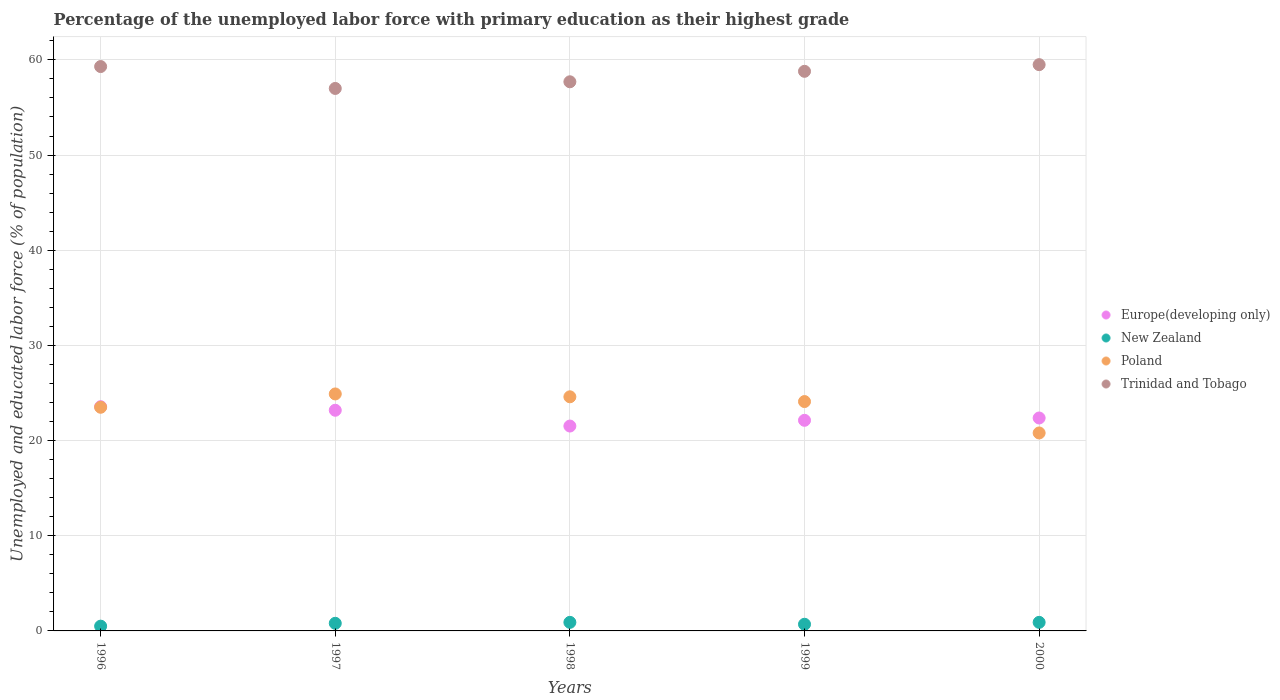How many different coloured dotlines are there?
Make the answer very short. 4. Is the number of dotlines equal to the number of legend labels?
Offer a terse response. Yes. What is the percentage of the unemployed labor force with primary education in Trinidad and Tobago in 2000?
Offer a very short reply. 59.5. Across all years, what is the maximum percentage of the unemployed labor force with primary education in Europe(developing only)?
Keep it short and to the point. 23.56. Across all years, what is the minimum percentage of the unemployed labor force with primary education in Trinidad and Tobago?
Your response must be concise. 57. In which year was the percentage of the unemployed labor force with primary education in Trinidad and Tobago maximum?
Offer a terse response. 2000. In which year was the percentage of the unemployed labor force with primary education in Europe(developing only) minimum?
Provide a succinct answer. 1998. What is the total percentage of the unemployed labor force with primary education in Poland in the graph?
Give a very brief answer. 117.9. What is the difference between the percentage of the unemployed labor force with primary education in New Zealand in 1997 and that in 1998?
Offer a terse response. -0.1. What is the difference between the percentage of the unemployed labor force with primary education in Poland in 1997 and the percentage of the unemployed labor force with primary education in Europe(developing only) in 1999?
Your answer should be compact. 2.77. What is the average percentage of the unemployed labor force with primary education in Europe(developing only) per year?
Make the answer very short. 22.56. In the year 1999, what is the difference between the percentage of the unemployed labor force with primary education in Poland and percentage of the unemployed labor force with primary education in Trinidad and Tobago?
Give a very brief answer. -34.7. What is the ratio of the percentage of the unemployed labor force with primary education in Poland in 1996 to that in 1997?
Give a very brief answer. 0.94. Is the percentage of the unemployed labor force with primary education in New Zealand in 1996 less than that in 2000?
Your answer should be very brief. Yes. What is the difference between the highest and the second highest percentage of the unemployed labor force with primary education in Trinidad and Tobago?
Ensure brevity in your answer.  0.2. What is the difference between the highest and the lowest percentage of the unemployed labor force with primary education in New Zealand?
Your answer should be compact. 0.4. Is the sum of the percentage of the unemployed labor force with primary education in New Zealand in 1997 and 1999 greater than the maximum percentage of the unemployed labor force with primary education in Europe(developing only) across all years?
Give a very brief answer. No. Is it the case that in every year, the sum of the percentage of the unemployed labor force with primary education in New Zealand and percentage of the unemployed labor force with primary education in Poland  is greater than the sum of percentage of the unemployed labor force with primary education in Europe(developing only) and percentage of the unemployed labor force with primary education in Trinidad and Tobago?
Make the answer very short. No. Is the percentage of the unemployed labor force with primary education in Europe(developing only) strictly greater than the percentage of the unemployed labor force with primary education in Trinidad and Tobago over the years?
Provide a succinct answer. No. How many dotlines are there?
Provide a short and direct response. 4. What is the difference between two consecutive major ticks on the Y-axis?
Your answer should be very brief. 10. Does the graph contain any zero values?
Keep it short and to the point. No. Does the graph contain grids?
Give a very brief answer. Yes. Where does the legend appear in the graph?
Your response must be concise. Center right. How many legend labels are there?
Offer a very short reply. 4. What is the title of the graph?
Your answer should be compact. Percentage of the unemployed labor force with primary education as their highest grade. What is the label or title of the Y-axis?
Provide a short and direct response. Unemployed and educated labor force (% of population). What is the Unemployed and educated labor force (% of population) of Europe(developing only) in 1996?
Make the answer very short. 23.56. What is the Unemployed and educated labor force (% of population) of New Zealand in 1996?
Offer a very short reply. 0.5. What is the Unemployed and educated labor force (% of population) of Trinidad and Tobago in 1996?
Your answer should be very brief. 59.3. What is the Unemployed and educated labor force (% of population) in Europe(developing only) in 1997?
Offer a terse response. 23.19. What is the Unemployed and educated labor force (% of population) in New Zealand in 1997?
Your response must be concise. 0.8. What is the Unemployed and educated labor force (% of population) of Poland in 1997?
Make the answer very short. 24.9. What is the Unemployed and educated labor force (% of population) of Trinidad and Tobago in 1997?
Your answer should be very brief. 57. What is the Unemployed and educated labor force (% of population) of Europe(developing only) in 1998?
Offer a very short reply. 21.53. What is the Unemployed and educated labor force (% of population) of New Zealand in 1998?
Offer a very short reply. 0.9. What is the Unemployed and educated labor force (% of population) of Poland in 1998?
Keep it short and to the point. 24.6. What is the Unemployed and educated labor force (% of population) in Trinidad and Tobago in 1998?
Offer a terse response. 57.7. What is the Unemployed and educated labor force (% of population) in Europe(developing only) in 1999?
Make the answer very short. 22.13. What is the Unemployed and educated labor force (% of population) of New Zealand in 1999?
Ensure brevity in your answer.  0.7. What is the Unemployed and educated labor force (% of population) of Poland in 1999?
Your answer should be compact. 24.1. What is the Unemployed and educated labor force (% of population) of Trinidad and Tobago in 1999?
Give a very brief answer. 58.8. What is the Unemployed and educated labor force (% of population) in Europe(developing only) in 2000?
Make the answer very short. 22.37. What is the Unemployed and educated labor force (% of population) in New Zealand in 2000?
Provide a succinct answer. 0.9. What is the Unemployed and educated labor force (% of population) of Poland in 2000?
Provide a succinct answer. 20.8. What is the Unemployed and educated labor force (% of population) of Trinidad and Tobago in 2000?
Your answer should be very brief. 59.5. Across all years, what is the maximum Unemployed and educated labor force (% of population) of Europe(developing only)?
Offer a terse response. 23.56. Across all years, what is the maximum Unemployed and educated labor force (% of population) of New Zealand?
Provide a succinct answer. 0.9. Across all years, what is the maximum Unemployed and educated labor force (% of population) of Poland?
Offer a terse response. 24.9. Across all years, what is the maximum Unemployed and educated labor force (% of population) in Trinidad and Tobago?
Keep it short and to the point. 59.5. Across all years, what is the minimum Unemployed and educated labor force (% of population) in Europe(developing only)?
Provide a short and direct response. 21.53. Across all years, what is the minimum Unemployed and educated labor force (% of population) of New Zealand?
Offer a very short reply. 0.5. Across all years, what is the minimum Unemployed and educated labor force (% of population) of Poland?
Keep it short and to the point. 20.8. What is the total Unemployed and educated labor force (% of population) of Europe(developing only) in the graph?
Your answer should be very brief. 112.78. What is the total Unemployed and educated labor force (% of population) of New Zealand in the graph?
Your answer should be compact. 3.8. What is the total Unemployed and educated labor force (% of population) of Poland in the graph?
Make the answer very short. 117.9. What is the total Unemployed and educated labor force (% of population) of Trinidad and Tobago in the graph?
Ensure brevity in your answer.  292.3. What is the difference between the Unemployed and educated labor force (% of population) of Europe(developing only) in 1996 and that in 1997?
Keep it short and to the point. 0.37. What is the difference between the Unemployed and educated labor force (% of population) of New Zealand in 1996 and that in 1997?
Provide a short and direct response. -0.3. What is the difference between the Unemployed and educated labor force (% of population) in Poland in 1996 and that in 1997?
Offer a very short reply. -1.4. What is the difference between the Unemployed and educated labor force (% of population) in Trinidad and Tobago in 1996 and that in 1997?
Provide a succinct answer. 2.3. What is the difference between the Unemployed and educated labor force (% of population) of Europe(developing only) in 1996 and that in 1998?
Ensure brevity in your answer.  2.03. What is the difference between the Unemployed and educated labor force (% of population) in Europe(developing only) in 1996 and that in 1999?
Your answer should be very brief. 1.43. What is the difference between the Unemployed and educated labor force (% of population) in New Zealand in 1996 and that in 1999?
Give a very brief answer. -0.2. What is the difference between the Unemployed and educated labor force (% of population) of Europe(developing only) in 1996 and that in 2000?
Your answer should be very brief. 1.19. What is the difference between the Unemployed and educated labor force (% of population) of Poland in 1996 and that in 2000?
Provide a succinct answer. 2.7. What is the difference between the Unemployed and educated labor force (% of population) in Europe(developing only) in 1997 and that in 1998?
Your response must be concise. 1.66. What is the difference between the Unemployed and educated labor force (% of population) in Poland in 1997 and that in 1998?
Offer a terse response. 0.3. What is the difference between the Unemployed and educated labor force (% of population) of Europe(developing only) in 1997 and that in 1999?
Your response must be concise. 1.06. What is the difference between the Unemployed and educated labor force (% of population) of Europe(developing only) in 1997 and that in 2000?
Your answer should be compact. 0.81. What is the difference between the Unemployed and educated labor force (% of population) in Trinidad and Tobago in 1997 and that in 2000?
Provide a succinct answer. -2.5. What is the difference between the Unemployed and educated labor force (% of population) in Europe(developing only) in 1998 and that in 1999?
Offer a terse response. -0.6. What is the difference between the Unemployed and educated labor force (% of population) in New Zealand in 1998 and that in 1999?
Offer a very short reply. 0.2. What is the difference between the Unemployed and educated labor force (% of population) in Poland in 1998 and that in 1999?
Provide a succinct answer. 0.5. What is the difference between the Unemployed and educated labor force (% of population) in Trinidad and Tobago in 1998 and that in 1999?
Offer a terse response. -1.1. What is the difference between the Unemployed and educated labor force (% of population) in Europe(developing only) in 1998 and that in 2000?
Your answer should be compact. -0.85. What is the difference between the Unemployed and educated labor force (% of population) in New Zealand in 1998 and that in 2000?
Ensure brevity in your answer.  0. What is the difference between the Unemployed and educated labor force (% of population) in Trinidad and Tobago in 1998 and that in 2000?
Provide a short and direct response. -1.8. What is the difference between the Unemployed and educated labor force (% of population) of Europe(developing only) in 1999 and that in 2000?
Your answer should be compact. -0.24. What is the difference between the Unemployed and educated labor force (% of population) in Europe(developing only) in 1996 and the Unemployed and educated labor force (% of population) in New Zealand in 1997?
Offer a terse response. 22.76. What is the difference between the Unemployed and educated labor force (% of population) of Europe(developing only) in 1996 and the Unemployed and educated labor force (% of population) of Poland in 1997?
Offer a terse response. -1.34. What is the difference between the Unemployed and educated labor force (% of population) of Europe(developing only) in 1996 and the Unemployed and educated labor force (% of population) of Trinidad and Tobago in 1997?
Your response must be concise. -33.44. What is the difference between the Unemployed and educated labor force (% of population) of New Zealand in 1996 and the Unemployed and educated labor force (% of population) of Poland in 1997?
Your response must be concise. -24.4. What is the difference between the Unemployed and educated labor force (% of population) in New Zealand in 1996 and the Unemployed and educated labor force (% of population) in Trinidad and Tobago in 1997?
Keep it short and to the point. -56.5. What is the difference between the Unemployed and educated labor force (% of population) of Poland in 1996 and the Unemployed and educated labor force (% of population) of Trinidad and Tobago in 1997?
Provide a short and direct response. -33.5. What is the difference between the Unemployed and educated labor force (% of population) of Europe(developing only) in 1996 and the Unemployed and educated labor force (% of population) of New Zealand in 1998?
Keep it short and to the point. 22.66. What is the difference between the Unemployed and educated labor force (% of population) in Europe(developing only) in 1996 and the Unemployed and educated labor force (% of population) in Poland in 1998?
Your response must be concise. -1.04. What is the difference between the Unemployed and educated labor force (% of population) in Europe(developing only) in 1996 and the Unemployed and educated labor force (% of population) in Trinidad and Tobago in 1998?
Ensure brevity in your answer.  -34.14. What is the difference between the Unemployed and educated labor force (% of population) in New Zealand in 1996 and the Unemployed and educated labor force (% of population) in Poland in 1998?
Provide a succinct answer. -24.1. What is the difference between the Unemployed and educated labor force (% of population) of New Zealand in 1996 and the Unemployed and educated labor force (% of population) of Trinidad and Tobago in 1998?
Your response must be concise. -57.2. What is the difference between the Unemployed and educated labor force (% of population) in Poland in 1996 and the Unemployed and educated labor force (% of population) in Trinidad and Tobago in 1998?
Provide a short and direct response. -34.2. What is the difference between the Unemployed and educated labor force (% of population) of Europe(developing only) in 1996 and the Unemployed and educated labor force (% of population) of New Zealand in 1999?
Make the answer very short. 22.86. What is the difference between the Unemployed and educated labor force (% of population) in Europe(developing only) in 1996 and the Unemployed and educated labor force (% of population) in Poland in 1999?
Offer a very short reply. -0.54. What is the difference between the Unemployed and educated labor force (% of population) of Europe(developing only) in 1996 and the Unemployed and educated labor force (% of population) of Trinidad and Tobago in 1999?
Your response must be concise. -35.24. What is the difference between the Unemployed and educated labor force (% of population) of New Zealand in 1996 and the Unemployed and educated labor force (% of population) of Poland in 1999?
Offer a terse response. -23.6. What is the difference between the Unemployed and educated labor force (% of population) of New Zealand in 1996 and the Unemployed and educated labor force (% of population) of Trinidad and Tobago in 1999?
Make the answer very short. -58.3. What is the difference between the Unemployed and educated labor force (% of population) in Poland in 1996 and the Unemployed and educated labor force (% of population) in Trinidad and Tobago in 1999?
Your answer should be very brief. -35.3. What is the difference between the Unemployed and educated labor force (% of population) of Europe(developing only) in 1996 and the Unemployed and educated labor force (% of population) of New Zealand in 2000?
Keep it short and to the point. 22.66. What is the difference between the Unemployed and educated labor force (% of population) in Europe(developing only) in 1996 and the Unemployed and educated labor force (% of population) in Poland in 2000?
Provide a short and direct response. 2.76. What is the difference between the Unemployed and educated labor force (% of population) in Europe(developing only) in 1996 and the Unemployed and educated labor force (% of population) in Trinidad and Tobago in 2000?
Ensure brevity in your answer.  -35.94. What is the difference between the Unemployed and educated labor force (% of population) in New Zealand in 1996 and the Unemployed and educated labor force (% of population) in Poland in 2000?
Provide a short and direct response. -20.3. What is the difference between the Unemployed and educated labor force (% of population) of New Zealand in 1996 and the Unemployed and educated labor force (% of population) of Trinidad and Tobago in 2000?
Ensure brevity in your answer.  -59. What is the difference between the Unemployed and educated labor force (% of population) in Poland in 1996 and the Unemployed and educated labor force (% of population) in Trinidad and Tobago in 2000?
Keep it short and to the point. -36. What is the difference between the Unemployed and educated labor force (% of population) in Europe(developing only) in 1997 and the Unemployed and educated labor force (% of population) in New Zealand in 1998?
Ensure brevity in your answer.  22.29. What is the difference between the Unemployed and educated labor force (% of population) of Europe(developing only) in 1997 and the Unemployed and educated labor force (% of population) of Poland in 1998?
Provide a succinct answer. -1.41. What is the difference between the Unemployed and educated labor force (% of population) in Europe(developing only) in 1997 and the Unemployed and educated labor force (% of population) in Trinidad and Tobago in 1998?
Offer a terse response. -34.51. What is the difference between the Unemployed and educated labor force (% of population) of New Zealand in 1997 and the Unemployed and educated labor force (% of population) of Poland in 1998?
Make the answer very short. -23.8. What is the difference between the Unemployed and educated labor force (% of population) in New Zealand in 1997 and the Unemployed and educated labor force (% of population) in Trinidad and Tobago in 1998?
Ensure brevity in your answer.  -56.9. What is the difference between the Unemployed and educated labor force (% of population) of Poland in 1997 and the Unemployed and educated labor force (% of population) of Trinidad and Tobago in 1998?
Your response must be concise. -32.8. What is the difference between the Unemployed and educated labor force (% of population) in Europe(developing only) in 1997 and the Unemployed and educated labor force (% of population) in New Zealand in 1999?
Your answer should be compact. 22.49. What is the difference between the Unemployed and educated labor force (% of population) of Europe(developing only) in 1997 and the Unemployed and educated labor force (% of population) of Poland in 1999?
Keep it short and to the point. -0.91. What is the difference between the Unemployed and educated labor force (% of population) of Europe(developing only) in 1997 and the Unemployed and educated labor force (% of population) of Trinidad and Tobago in 1999?
Your response must be concise. -35.61. What is the difference between the Unemployed and educated labor force (% of population) in New Zealand in 1997 and the Unemployed and educated labor force (% of population) in Poland in 1999?
Keep it short and to the point. -23.3. What is the difference between the Unemployed and educated labor force (% of population) in New Zealand in 1997 and the Unemployed and educated labor force (% of population) in Trinidad and Tobago in 1999?
Your answer should be very brief. -58. What is the difference between the Unemployed and educated labor force (% of population) of Poland in 1997 and the Unemployed and educated labor force (% of population) of Trinidad and Tobago in 1999?
Ensure brevity in your answer.  -33.9. What is the difference between the Unemployed and educated labor force (% of population) of Europe(developing only) in 1997 and the Unemployed and educated labor force (% of population) of New Zealand in 2000?
Provide a succinct answer. 22.29. What is the difference between the Unemployed and educated labor force (% of population) of Europe(developing only) in 1997 and the Unemployed and educated labor force (% of population) of Poland in 2000?
Give a very brief answer. 2.39. What is the difference between the Unemployed and educated labor force (% of population) in Europe(developing only) in 1997 and the Unemployed and educated labor force (% of population) in Trinidad and Tobago in 2000?
Offer a terse response. -36.31. What is the difference between the Unemployed and educated labor force (% of population) of New Zealand in 1997 and the Unemployed and educated labor force (% of population) of Trinidad and Tobago in 2000?
Your answer should be very brief. -58.7. What is the difference between the Unemployed and educated labor force (% of population) in Poland in 1997 and the Unemployed and educated labor force (% of population) in Trinidad and Tobago in 2000?
Offer a terse response. -34.6. What is the difference between the Unemployed and educated labor force (% of population) in Europe(developing only) in 1998 and the Unemployed and educated labor force (% of population) in New Zealand in 1999?
Your answer should be very brief. 20.83. What is the difference between the Unemployed and educated labor force (% of population) of Europe(developing only) in 1998 and the Unemployed and educated labor force (% of population) of Poland in 1999?
Ensure brevity in your answer.  -2.57. What is the difference between the Unemployed and educated labor force (% of population) in Europe(developing only) in 1998 and the Unemployed and educated labor force (% of population) in Trinidad and Tobago in 1999?
Make the answer very short. -37.27. What is the difference between the Unemployed and educated labor force (% of population) of New Zealand in 1998 and the Unemployed and educated labor force (% of population) of Poland in 1999?
Offer a very short reply. -23.2. What is the difference between the Unemployed and educated labor force (% of population) in New Zealand in 1998 and the Unemployed and educated labor force (% of population) in Trinidad and Tobago in 1999?
Your answer should be compact. -57.9. What is the difference between the Unemployed and educated labor force (% of population) of Poland in 1998 and the Unemployed and educated labor force (% of population) of Trinidad and Tobago in 1999?
Your answer should be compact. -34.2. What is the difference between the Unemployed and educated labor force (% of population) of Europe(developing only) in 1998 and the Unemployed and educated labor force (% of population) of New Zealand in 2000?
Keep it short and to the point. 20.63. What is the difference between the Unemployed and educated labor force (% of population) of Europe(developing only) in 1998 and the Unemployed and educated labor force (% of population) of Poland in 2000?
Give a very brief answer. 0.73. What is the difference between the Unemployed and educated labor force (% of population) of Europe(developing only) in 1998 and the Unemployed and educated labor force (% of population) of Trinidad and Tobago in 2000?
Keep it short and to the point. -37.97. What is the difference between the Unemployed and educated labor force (% of population) in New Zealand in 1998 and the Unemployed and educated labor force (% of population) in Poland in 2000?
Make the answer very short. -19.9. What is the difference between the Unemployed and educated labor force (% of population) of New Zealand in 1998 and the Unemployed and educated labor force (% of population) of Trinidad and Tobago in 2000?
Your answer should be very brief. -58.6. What is the difference between the Unemployed and educated labor force (% of population) in Poland in 1998 and the Unemployed and educated labor force (% of population) in Trinidad and Tobago in 2000?
Provide a succinct answer. -34.9. What is the difference between the Unemployed and educated labor force (% of population) of Europe(developing only) in 1999 and the Unemployed and educated labor force (% of population) of New Zealand in 2000?
Ensure brevity in your answer.  21.23. What is the difference between the Unemployed and educated labor force (% of population) in Europe(developing only) in 1999 and the Unemployed and educated labor force (% of population) in Poland in 2000?
Give a very brief answer. 1.33. What is the difference between the Unemployed and educated labor force (% of population) of Europe(developing only) in 1999 and the Unemployed and educated labor force (% of population) of Trinidad and Tobago in 2000?
Your answer should be very brief. -37.37. What is the difference between the Unemployed and educated labor force (% of population) in New Zealand in 1999 and the Unemployed and educated labor force (% of population) in Poland in 2000?
Provide a short and direct response. -20.1. What is the difference between the Unemployed and educated labor force (% of population) of New Zealand in 1999 and the Unemployed and educated labor force (% of population) of Trinidad and Tobago in 2000?
Offer a very short reply. -58.8. What is the difference between the Unemployed and educated labor force (% of population) in Poland in 1999 and the Unemployed and educated labor force (% of population) in Trinidad and Tobago in 2000?
Your response must be concise. -35.4. What is the average Unemployed and educated labor force (% of population) in Europe(developing only) per year?
Your answer should be compact. 22.56. What is the average Unemployed and educated labor force (% of population) of New Zealand per year?
Offer a terse response. 0.76. What is the average Unemployed and educated labor force (% of population) of Poland per year?
Provide a succinct answer. 23.58. What is the average Unemployed and educated labor force (% of population) in Trinidad and Tobago per year?
Your answer should be very brief. 58.46. In the year 1996, what is the difference between the Unemployed and educated labor force (% of population) of Europe(developing only) and Unemployed and educated labor force (% of population) of New Zealand?
Offer a terse response. 23.06. In the year 1996, what is the difference between the Unemployed and educated labor force (% of population) in Europe(developing only) and Unemployed and educated labor force (% of population) in Poland?
Provide a short and direct response. 0.06. In the year 1996, what is the difference between the Unemployed and educated labor force (% of population) in Europe(developing only) and Unemployed and educated labor force (% of population) in Trinidad and Tobago?
Keep it short and to the point. -35.74. In the year 1996, what is the difference between the Unemployed and educated labor force (% of population) of New Zealand and Unemployed and educated labor force (% of population) of Poland?
Offer a very short reply. -23. In the year 1996, what is the difference between the Unemployed and educated labor force (% of population) in New Zealand and Unemployed and educated labor force (% of population) in Trinidad and Tobago?
Make the answer very short. -58.8. In the year 1996, what is the difference between the Unemployed and educated labor force (% of population) in Poland and Unemployed and educated labor force (% of population) in Trinidad and Tobago?
Ensure brevity in your answer.  -35.8. In the year 1997, what is the difference between the Unemployed and educated labor force (% of population) of Europe(developing only) and Unemployed and educated labor force (% of population) of New Zealand?
Ensure brevity in your answer.  22.39. In the year 1997, what is the difference between the Unemployed and educated labor force (% of population) of Europe(developing only) and Unemployed and educated labor force (% of population) of Poland?
Ensure brevity in your answer.  -1.71. In the year 1997, what is the difference between the Unemployed and educated labor force (% of population) in Europe(developing only) and Unemployed and educated labor force (% of population) in Trinidad and Tobago?
Keep it short and to the point. -33.81. In the year 1997, what is the difference between the Unemployed and educated labor force (% of population) in New Zealand and Unemployed and educated labor force (% of population) in Poland?
Your response must be concise. -24.1. In the year 1997, what is the difference between the Unemployed and educated labor force (% of population) in New Zealand and Unemployed and educated labor force (% of population) in Trinidad and Tobago?
Your response must be concise. -56.2. In the year 1997, what is the difference between the Unemployed and educated labor force (% of population) in Poland and Unemployed and educated labor force (% of population) in Trinidad and Tobago?
Keep it short and to the point. -32.1. In the year 1998, what is the difference between the Unemployed and educated labor force (% of population) in Europe(developing only) and Unemployed and educated labor force (% of population) in New Zealand?
Keep it short and to the point. 20.63. In the year 1998, what is the difference between the Unemployed and educated labor force (% of population) of Europe(developing only) and Unemployed and educated labor force (% of population) of Poland?
Your answer should be compact. -3.07. In the year 1998, what is the difference between the Unemployed and educated labor force (% of population) in Europe(developing only) and Unemployed and educated labor force (% of population) in Trinidad and Tobago?
Offer a terse response. -36.17. In the year 1998, what is the difference between the Unemployed and educated labor force (% of population) in New Zealand and Unemployed and educated labor force (% of population) in Poland?
Offer a terse response. -23.7. In the year 1998, what is the difference between the Unemployed and educated labor force (% of population) of New Zealand and Unemployed and educated labor force (% of population) of Trinidad and Tobago?
Provide a succinct answer. -56.8. In the year 1998, what is the difference between the Unemployed and educated labor force (% of population) of Poland and Unemployed and educated labor force (% of population) of Trinidad and Tobago?
Your answer should be very brief. -33.1. In the year 1999, what is the difference between the Unemployed and educated labor force (% of population) in Europe(developing only) and Unemployed and educated labor force (% of population) in New Zealand?
Ensure brevity in your answer.  21.43. In the year 1999, what is the difference between the Unemployed and educated labor force (% of population) of Europe(developing only) and Unemployed and educated labor force (% of population) of Poland?
Ensure brevity in your answer.  -1.97. In the year 1999, what is the difference between the Unemployed and educated labor force (% of population) in Europe(developing only) and Unemployed and educated labor force (% of population) in Trinidad and Tobago?
Your response must be concise. -36.67. In the year 1999, what is the difference between the Unemployed and educated labor force (% of population) of New Zealand and Unemployed and educated labor force (% of population) of Poland?
Offer a terse response. -23.4. In the year 1999, what is the difference between the Unemployed and educated labor force (% of population) in New Zealand and Unemployed and educated labor force (% of population) in Trinidad and Tobago?
Make the answer very short. -58.1. In the year 1999, what is the difference between the Unemployed and educated labor force (% of population) of Poland and Unemployed and educated labor force (% of population) of Trinidad and Tobago?
Your response must be concise. -34.7. In the year 2000, what is the difference between the Unemployed and educated labor force (% of population) of Europe(developing only) and Unemployed and educated labor force (% of population) of New Zealand?
Your answer should be compact. 21.47. In the year 2000, what is the difference between the Unemployed and educated labor force (% of population) of Europe(developing only) and Unemployed and educated labor force (% of population) of Poland?
Your response must be concise. 1.57. In the year 2000, what is the difference between the Unemployed and educated labor force (% of population) of Europe(developing only) and Unemployed and educated labor force (% of population) of Trinidad and Tobago?
Give a very brief answer. -37.13. In the year 2000, what is the difference between the Unemployed and educated labor force (% of population) in New Zealand and Unemployed and educated labor force (% of population) in Poland?
Offer a very short reply. -19.9. In the year 2000, what is the difference between the Unemployed and educated labor force (% of population) in New Zealand and Unemployed and educated labor force (% of population) in Trinidad and Tobago?
Keep it short and to the point. -58.6. In the year 2000, what is the difference between the Unemployed and educated labor force (% of population) of Poland and Unemployed and educated labor force (% of population) of Trinidad and Tobago?
Give a very brief answer. -38.7. What is the ratio of the Unemployed and educated labor force (% of population) in Europe(developing only) in 1996 to that in 1997?
Your answer should be very brief. 1.02. What is the ratio of the Unemployed and educated labor force (% of population) of New Zealand in 1996 to that in 1997?
Provide a short and direct response. 0.62. What is the ratio of the Unemployed and educated labor force (% of population) of Poland in 1996 to that in 1997?
Provide a short and direct response. 0.94. What is the ratio of the Unemployed and educated labor force (% of population) in Trinidad and Tobago in 1996 to that in 1997?
Your answer should be very brief. 1.04. What is the ratio of the Unemployed and educated labor force (% of population) in Europe(developing only) in 1996 to that in 1998?
Provide a short and direct response. 1.09. What is the ratio of the Unemployed and educated labor force (% of population) in New Zealand in 1996 to that in 1998?
Offer a terse response. 0.56. What is the ratio of the Unemployed and educated labor force (% of population) in Poland in 1996 to that in 1998?
Offer a very short reply. 0.96. What is the ratio of the Unemployed and educated labor force (% of population) of Trinidad and Tobago in 1996 to that in 1998?
Provide a succinct answer. 1.03. What is the ratio of the Unemployed and educated labor force (% of population) in Europe(developing only) in 1996 to that in 1999?
Ensure brevity in your answer.  1.06. What is the ratio of the Unemployed and educated labor force (% of population) in Poland in 1996 to that in 1999?
Your response must be concise. 0.98. What is the ratio of the Unemployed and educated labor force (% of population) in Trinidad and Tobago in 1996 to that in 1999?
Make the answer very short. 1.01. What is the ratio of the Unemployed and educated labor force (% of population) of Europe(developing only) in 1996 to that in 2000?
Offer a very short reply. 1.05. What is the ratio of the Unemployed and educated labor force (% of population) in New Zealand in 1996 to that in 2000?
Give a very brief answer. 0.56. What is the ratio of the Unemployed and educated labor force (% of population) in Poland in 1996 to that in 2000?
Provide a succinct answer. 1.13. What is the ratio of the Unemployed and educated labor force (% of population) in Trinidad and Tobago in 1996 to that in 2000?
Your response must be concise. 1. What is the ratio of the Unemployed and educated labor force (% of population) of Europe(developing only) in 1997 to that in 1998?
Your answer should be very brief. 1.08. What is the ratio of the Unemployed and educated labor force (% of population) of Poland in 1997 to that in 1998?
Your answer should be very brief. 1.01. What is the ratio of the Unemployed and educated labor force (% of population) in Trinidad and Tobago in 1997 to that in 1998?
Offer a terse response. 0.99. What is the ratio of the Unemployed and educated labor force (% of population) in Europe(developing only) in 1997 to that in 1999?
Provide a short and direct response. 1.05. What is the ratio of the Unemployed and educated labor force (% of population) in New Zealand in 1997 to that in 1999?
Ensure brevity in your answer.  1.14. What is the ratio of the Unemployed and educated labor force (% of population) of Poland in 1997 to that in 1999?
Keep it short and to the point. 1.03. What is the ratio of the Unemployed and educated labor force (% of population) in Trinidad and Tobago in 1997 to that in 1999?
Keep it short and to the point. 0.97. What is the ratio of the Unemployed and educated labor force (% of population) in Europe(developing only) in 1997 to that in 2000?
Make the answer very short. 1.04. What is the ratio of the Unemployed and educated labor force (% of population) in Poland in 1997 to that in 2000?
Provide a succinct answer. 1.2. What is the ratio of the Unemployed and educated labor force (% of population) in Trinidad and Tobago in 1997 to that in 2000?
Give a very brief answer. 0.96. What is the ratio of the Unemployed and educated labor force (% of population) in Europe(developing only) in 1998 to that in 1999?
Make the answer very short. 0.97. What is the ratio of the Unemployed and educated labor force (% of population) in Poland in 1998 to that in 1999?
Your response must be concise. 1.02. What is the ratio of the Unemployed and educated labor force (% of population) in Trinidad and Tobago in 1998 to that in 1999?
Offer a terse response. 0.98. What is the ratio of the Unemployed and educated labor force (% of population) in Europe(developing only) in 1998 to that in 2000?
Provide a short and direct response. 0.96. What is the ratio of the Unemployed and educated labor force (% of population) of Poland in 1998 to that in 2000?
Make the answer very short. 1.18. What is the ratio of the Unemployed and educated labor force (% of population) in Trinidad and Tobago in 1998 to that in 2000?
Ensure brevity in your answer.  0.97. What is the ratio of the Unemployed and educated labor force (% of population) in Europe(developing only) in 1999 to that in 2000?
Make the answer very short. 0.99. What is the ratio of the Unemployed and educated labor force (% of population) in Poland in 1999 to that in 2000?
Your answer should be compact. 1.16. What is the ratio of the Unemployed and educated labor force (% of population) in Trinidad and Tobago in 1999 to that in 2000?
Provide a short and direct response. 0.99. What is the difference between the highest and the second highest Unemployed and educated labor force (% of population) of Europe(developing only)?
Your response must be concise. 0.37. What is the difference between the highest and the second highest Unemployed and educated labor force (% of population) of Poland?
Provide a short and direct response. 0.3. What is the difference between the highest and the second highest Unemployed and educated labor force (% of population) of Trinidad and Tobago?
Your answer should be very brief. 0.2. What is the difference between the highest and the lowest Unemployed and educated labor force (% of population) in Europe(developing only)?
Provide a succinct answer. 2.03. What is the difference between the highest and the lowest Unemployed and educated labor force (% of population) in New Zealand?
Provide a succinct answer. 0.4. 